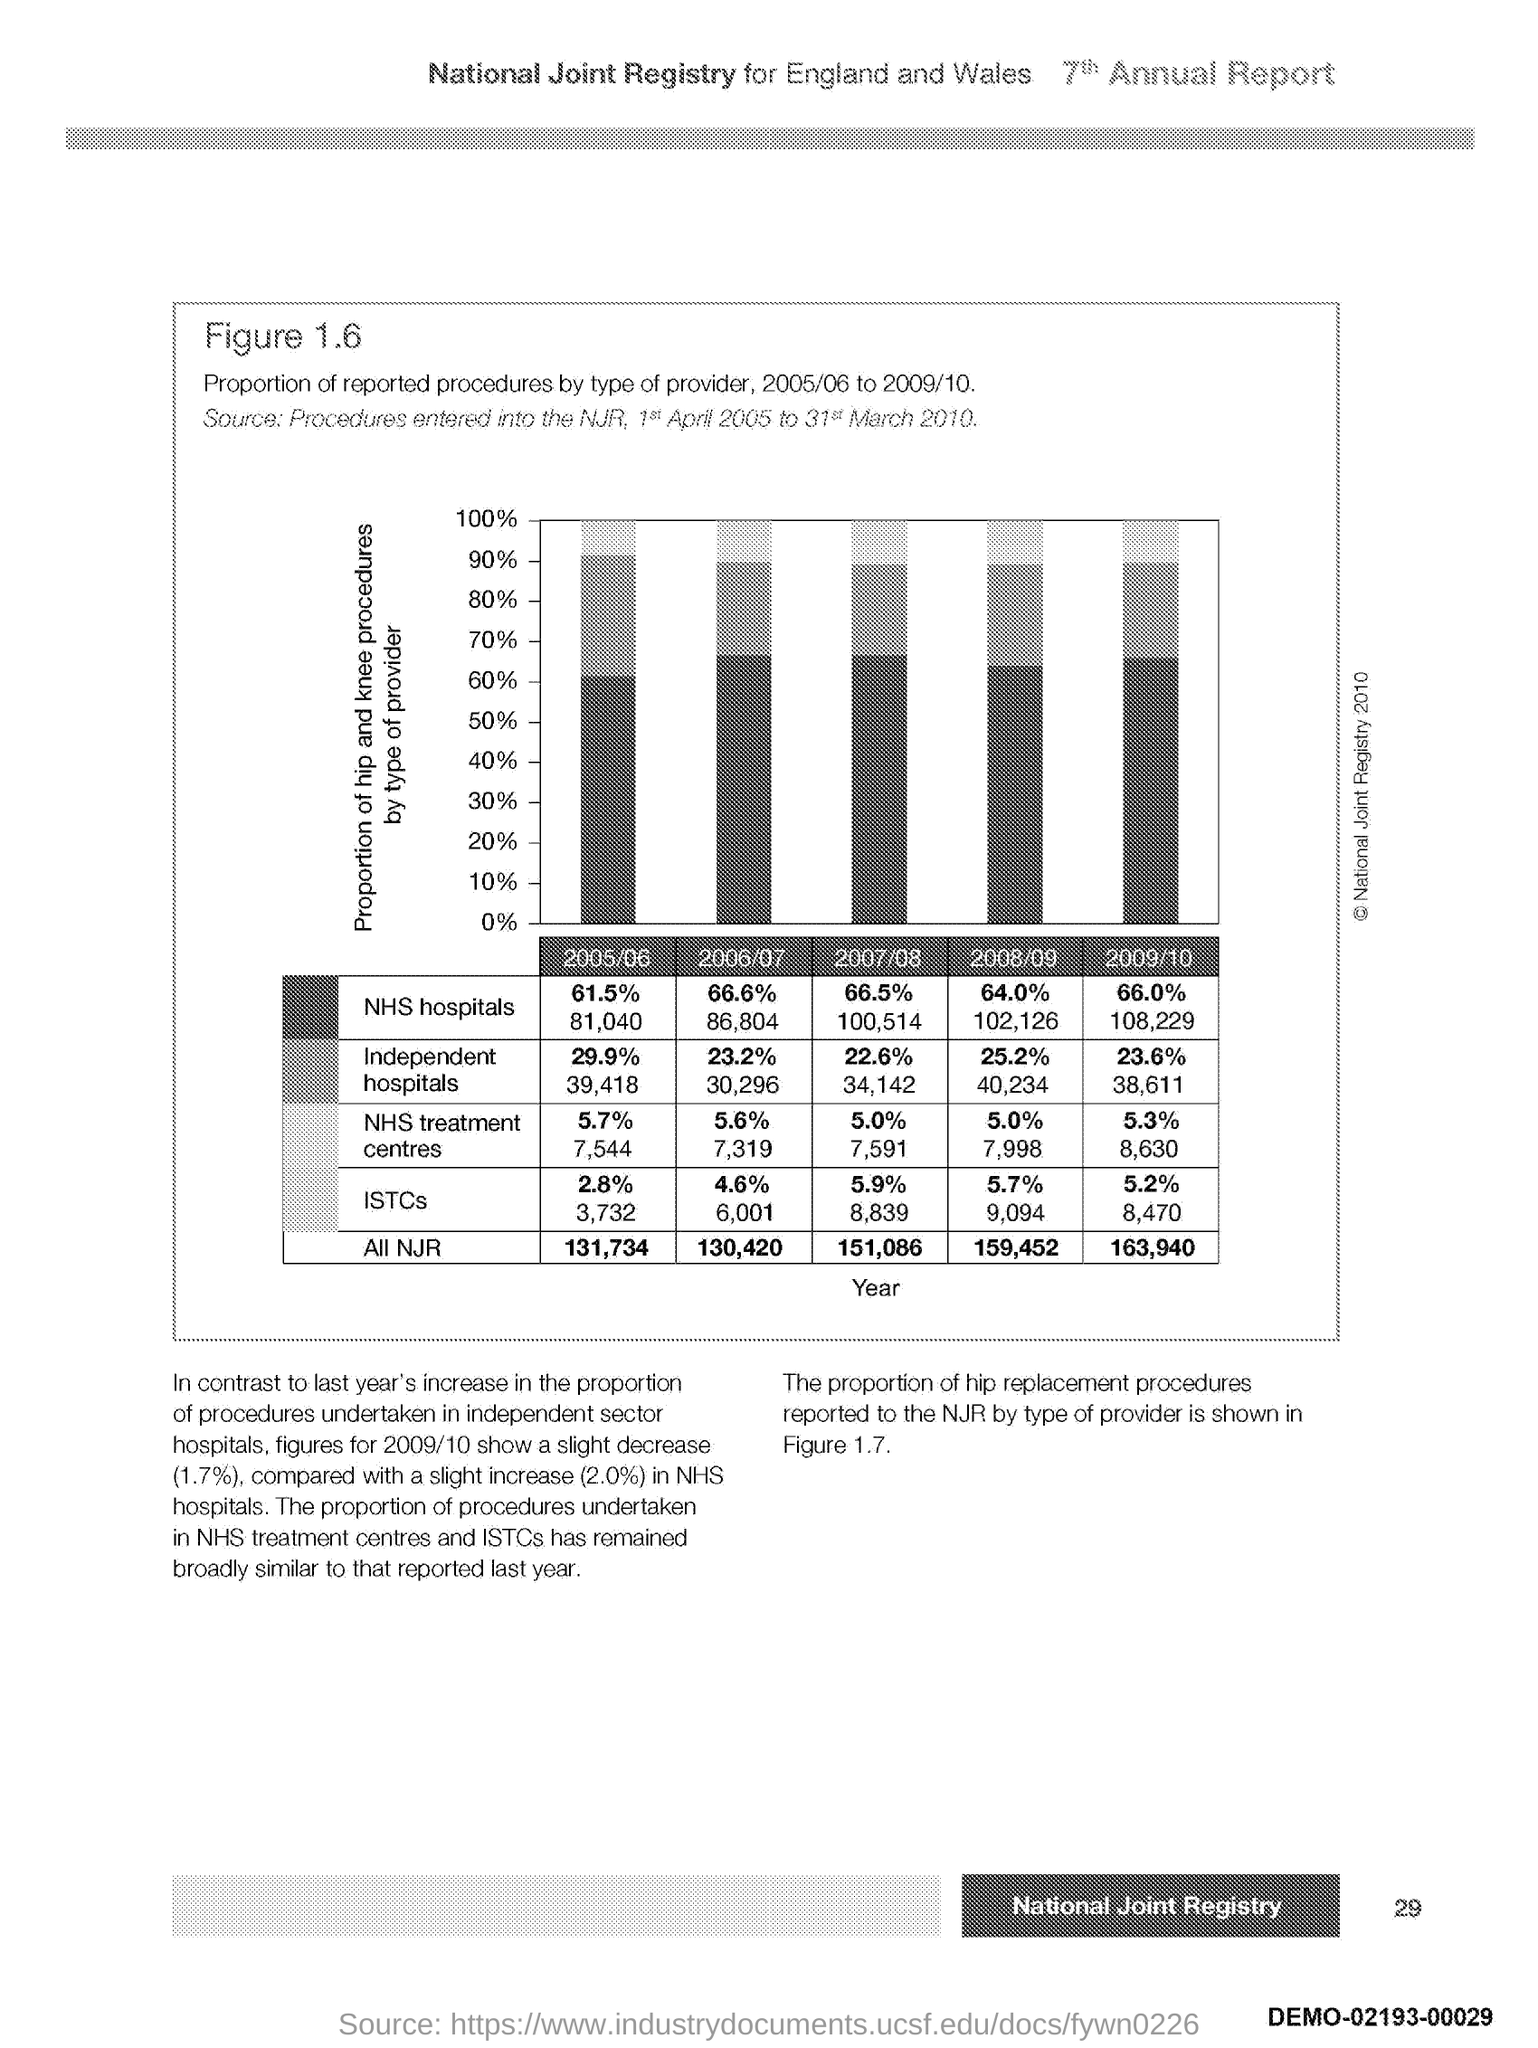What is in the x-axis?
Offer a very short reply. Year. 